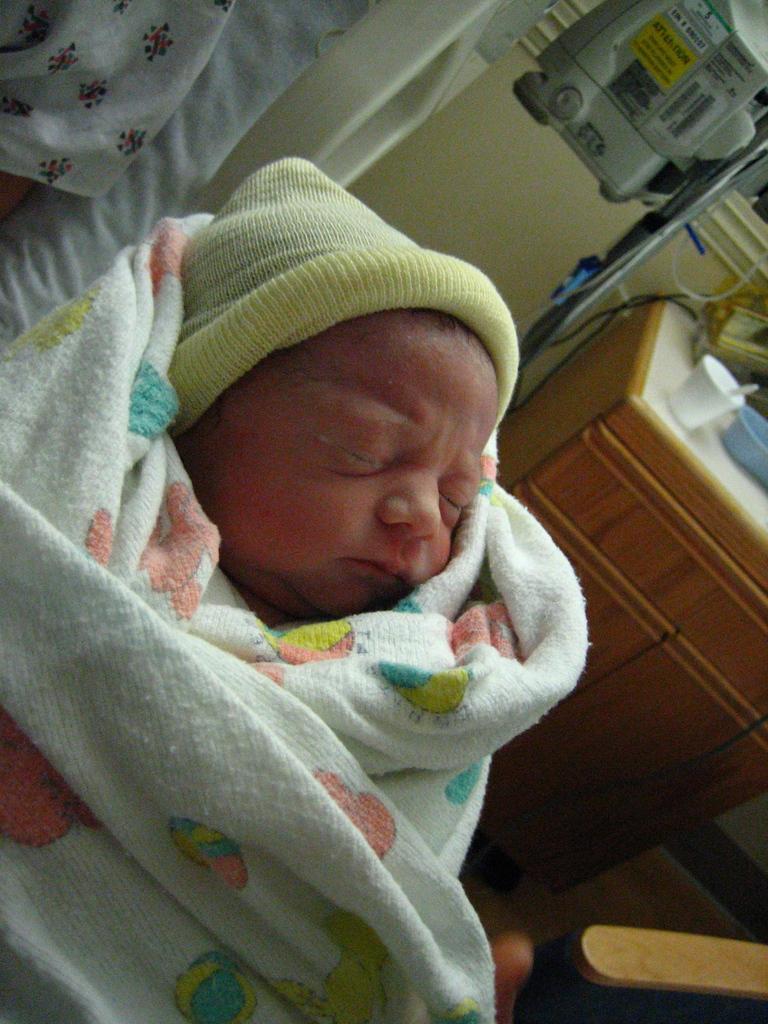Could you give a brief overview of what you see in this image? In this image I can see baby is in the white color towel and wearing yellow color cap. Back Side I can see cup,spoon and some objects on the cupboard. We can see machine and a wall. 